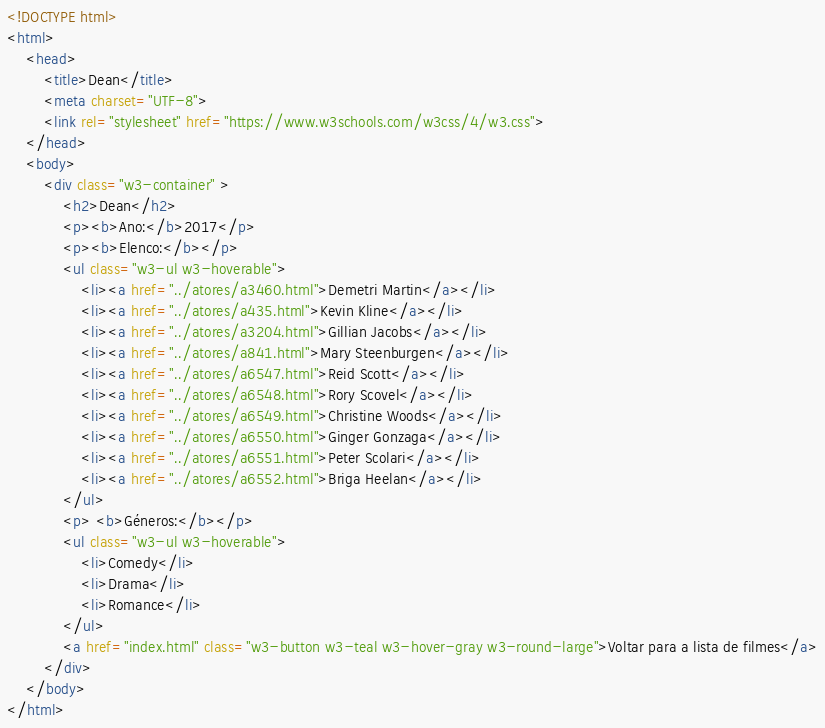<code> <loc_0><loc_0><loc_500><loc_500><_HTML_><!DOCTYPE html>
<html>
    <head>
        <title>Dean</title>
        <meta charset="UTF-8">
        <link rel="stylesheet" href="https://www.w3schools.com/w3css/4/w3.css">
    </head>
    <body>
        <div class="w3-container" >
            <h2>Dean</h2>
            <p><b>Ano:</b>2017</p>
            <p><b>Elenco:</b></p>
            <ul class="w3-ul w3-hoverable">
				<li><a href="../atores/a3460.html">Demetri Martin</a></li>
				<li><a href="../atores/a435.html">Kevin Kline</a></li>
				<li><a href="../atores/a3204.html">Gillian Jacobs</a></li>
				<li><a href="../atores/a841.html">Mary Steenburgen</a></li>
				<li><a href="../atores/a6547.html">Reid Scott</a></li>
				<li><a href="../atores/a6548.html">Rory Scovel</a></li>
				<li><a href="../atores/a6549.html">Christine Woods</a></li>
				<li><a href="../atores/a6550.html">Ginger Gonzaga</a></li>
				<li><a href="../atores/a6551.html">Peter Scolari</a></li>
				<li><a href="../atores/a6552.html">Briga Heelan</a></li>
			</ul>
            <p> <b>Géneros:</b></p>
            <ul class="w3-ul w3-hoverable">
				<li>Comedy</li>
				<li>Drama</li>
				<li>Romance</li>
			</ul>
            <a href="index.html" class="w3-button w3-teal w3-hover-gray w3-round-large">Voltar para a lista de filmes</a>
        </div>
    </body>
</html></code> 